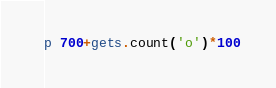Convert code to text. <code><loc_0><loc_0><loc_500><loc_500><_Ruby_>p 700+gets.count('o')*100</code> 